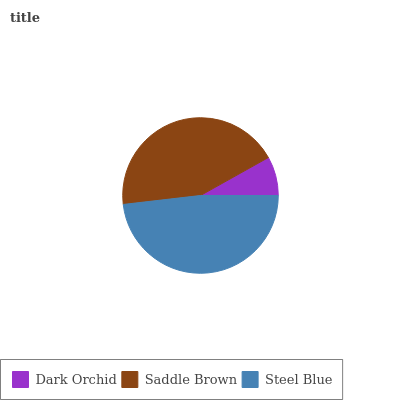Is Dark Orchid the minimum?
Answer yes or no. Yes. Is Steel Blue the maximum?
Answer yes or no. Yes. Is Saddle Brown the minimum?
Answer yes or no. No. Is Saddle Brown the maximum?
Answer yes or no. No. Is Saddle Brown greater than Dark Orchid?
Answer yes or no. Yes. Is Dark Orchid less than Saddle Brown?
Answer yes or no. Yes. Is Dark Orchid greater than Saddle Brown?
Answer yes or no. No. Is Saddle Brown less than Dark Orchid?
Answer yes or no. No. Is Saddle Brown the high median?
Answer yes or no. Yes. Is Saddle Brown the low median?
Answer yes or no. Yes. Is Steel Blue the high median?
Answer yes or no. No. Is Dark Orchid the low median?
Answer yes or no. No. 